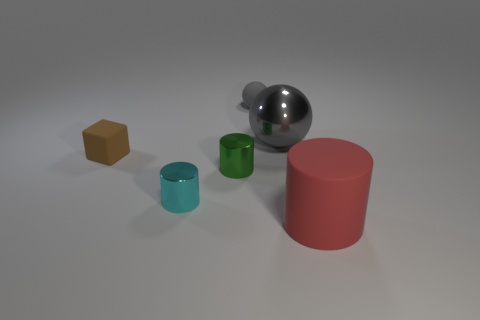Is the material of the cylinder that is to the left of the green metal cylinder the same as the cylinder in front of the small cyan thing?
Give a very brief answer. No. What shape is the gray object right of the tiny rubber ball?
Provide a short and direct response. Sphere. There is a gray matte thing that is the same shape as the gray metal thing; what is its size?
Provide a succinct answer. Small. Does the tiny ball have the same color as the matte block?
Keep it short and to the point. No. Is there anything else that is the same shape as the green object?
Ensure brevity in your answer.  Yes. Are there any tiny gray matte spheres that are to the right of the large thing that is behind the brown matte block?
Ensure brevity in your answer.  No. What color is the other tiny metal object that is the same shape as the green shiny object?
Offer a very short reply. Cyan. How many big shiny things have the same color as the tiny rubber ball?
Keep it short and to the point. 1. There is a cylinder that is right of the sphere to the left of the big thing behind the red rubber thing; what is its color?
Keep it short and to the point. Red. Is the material of the big red object the same as the small gray sphere?
Your answer should be compact. Yes. 